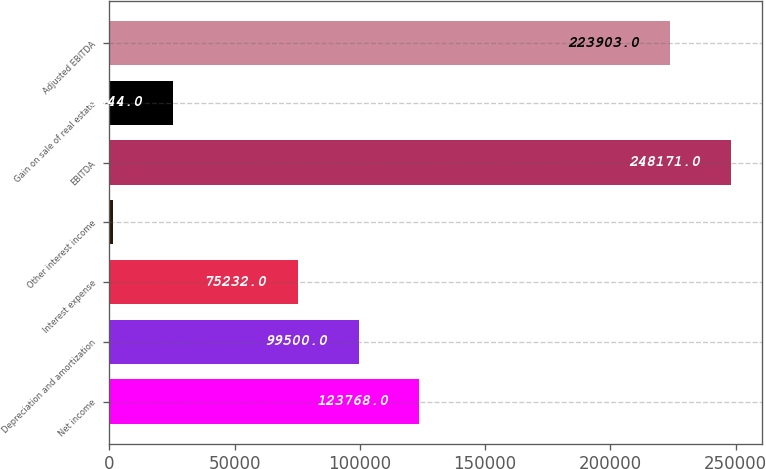Convert chart to OTSL. <chart><loc_0><loc_0><loc_500><loc_500><bar_chart><fcel>Net income<fcel>Depreciation and amortization<fcel>Interest expense<fcel>Other interest income<fcel>EBITDA<fcel>Gain on sale of real estate<fcel>Adjusted EBITDA<nl><fcel>123768<fcel>99500<fcel>75232<fcel>1276<fcel>248171<fcel>25544<fcel>223903<nl></chart> 